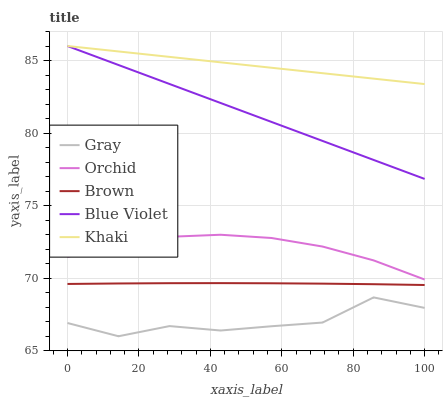Does Gray have the minimum area under the curve?
Answer yes or no. Yes. Does Khaki have the maximum area under the curve?
Answer yes or no. Yes. Does Brown have the minimum area under the curve?
Answer yes or no. No. Does Brown have the maximum area under the curve?
Answer yes or no. No. Is Blue Violet the smoothest?
Answer yes or no. Yes. Is Gray the roughest?
Answer yes or no. Yes. Is Khaki the smoothest?
Answer yes or no. No. Is Khaki the roughest?
Answer yes or no. No. Does Brown have the lowest value?
Answer yes or no. No. Does Blue Violet have the highest value?
Answer yes or no. Yes. Does Brown have the highest value?
Answer yes or no. No. Is Brown less than Orchid?
Answer yes or no. Yes. Is Brown greater than Gray?
Answer yes or no. Yes. Does Khaki intersect Blue Violet?
Answer yes or no. Yes. Is Khaki less than Blue Violet?
Answer yes or no. No. Is Khaki greater than Blue Violet?
Answer yes or no. No. Does Brown intersect Orchid?
Answer yes or no. No. 